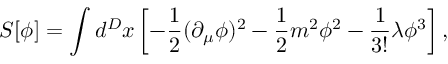Convert formula to latex. <formula><loc_0><loc_0><loc_500><loc_500>S [ \phi ] = \int d ^ { D } x \left [ - { \frac { 1 } { 2 } } ( \partial _ { \mu } \phi ) ^ { 2 } - { \frac { 1 } { 2 } } m ^ { 2 } \phi ^ { 2 } - { \frac { 1 } { 3 ! } } \lambda \phi ^ { 3 } \right ] ,</formula> 